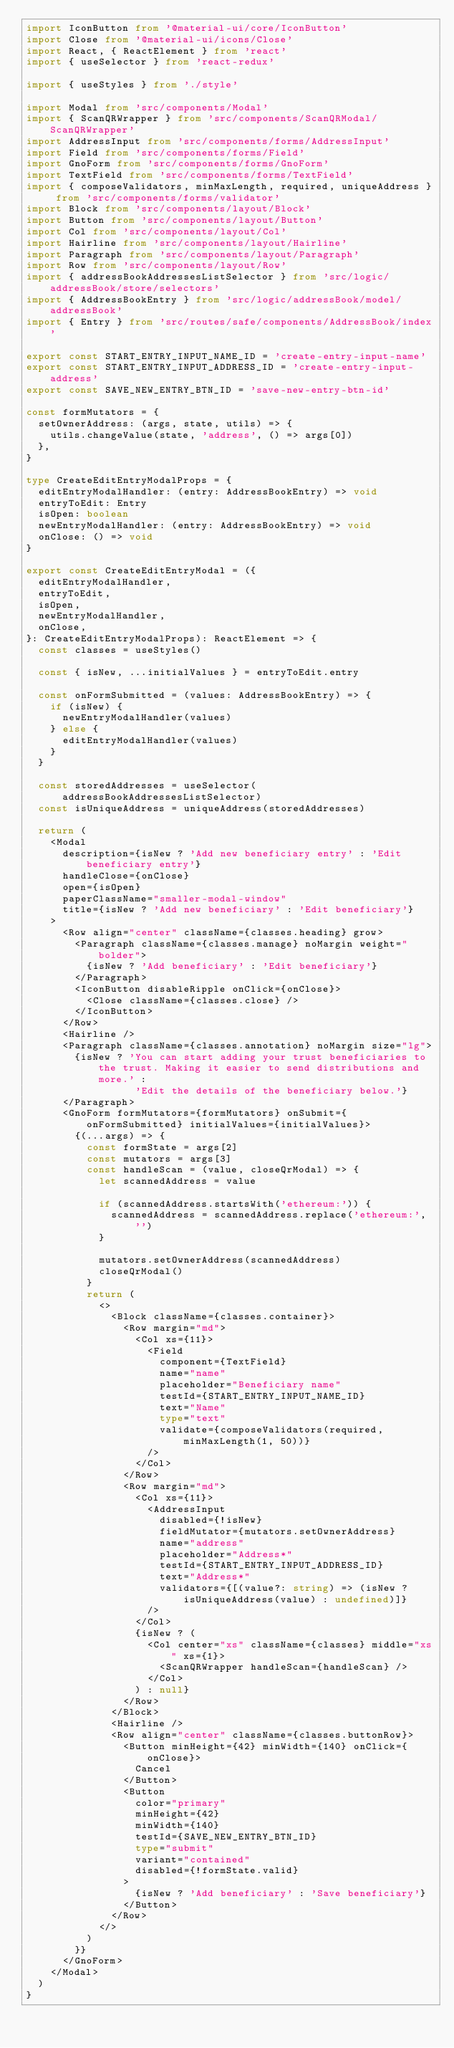<code> <loc_0><loc_0><loc_500><loc_500><_TypeScript_>import IconButton from '@material-ui/core/IconButton'
import Close from '@material-ui/icons/Close'
import React, { ReactElement } from 'react'
import { useSelector } from 'react-redux'

import { useStyles } from './style'

import Modal from 'src/components/Modal'
import { ScanQRWrapper } from 'src/components/ScanQRModal/ScanQRWrapper'
import AddressInput from 'src/components/forms/AddressInput'
import Field from 'src/components/forms/Field'
import GnoForm from 'src/components/forms/GnoForm'
import TextField from 'src/components/forms/TextField'
import { composeValidators, minMaxLength, required, uniqueAddress } from 'src/components/forms/validator'
import Block from 'src/components/layout/Block'
import Button from 'src/components/layout/Button'
import Col from 'src/components/layout/Col'
import Hairline from 'src/components/layout/Hairline'
import Paragraph from 'src/components/layout/Paragraph'
import Row from 'src/components/layout/Row'
import { addressBookAddressesListSelector } from 'src/logic/addressBook/store/selectors'
import { AddressBookEntry } from 'src/logic/addressBook/model/addressBook'
import { Entry } from 'src/routes/safe/components/AddressBook/index'

export const START_ENTRY_INPUT_NAME_ID = 'create-entry-input-name'
export const START_ENTRY_INPUT_ADDRESS_ID = 'create-entry-input-address'
export const SAVE_NEW_ENTRY_BTN_ID = 'save-new-entry-btn-id'

const formMutators = {
  setOwnerAddress: (args, state, utils) => {
    utils.changeValue(state, 'address', () => args[0])
  },
}

type CreateEditEntryModalProps = {
  editEntryModalHandler: (entry: AddressBookEntry) => void
  entryToEdit: Entry
  isOpen: boolean
  newEntryModalHandler: (entry: AddressBookEntry) => void
  onClose: () => void
}

export const CreateEditEntryModal = ({
  editEntryModalHandler,
  entryToEdit,
  isOpen,
  newEntryModalHandler,
  onClose,
}: CreateEditEntryModalProps): ReactElement => {
  const classes = useStyles()

  const { isNew, ...initialValues } = entryToEdit.entry

  const onFormSubmitted = (values: AddressBookEntry) => {
    if (isNew) {
      newEntryModalHandler(values)
    } else {
      editEntryModalHandler(values)
    }
  }

  const storedAddresses = useSelector(addressBookAddressesListSelector)
  const isUniqueAddress = uniqueAddress(storedAddresses)

  return (
    <Modal
      description={isNew ? 'Add new beneficiary entry' : 'Edit beneficiary entry'}
      handleClose={onClose}
      open={isOpen}
      paperClassName="smaller-modal-window"
      title={isNew ? 'Add new beneficiary' : 'Edit beneficiary'}
    >
      <Row align="center" className={classes.heading} grow>
        <Paragraph className={classes.manage} noMargin weight="bolder">
          {isNew ? 'Add beneficiary' : 'Edit beneficiary'}
        </Paragraph>
        <IconButton disableRipple onClick={onClose}>
          <Close className={classes.close} />
        </IconButton>
      </Row>
      <Hairline />
      <Paragraph className={classes.annotation} noMargin size="lg">
        {isNew ? 'You can start adding your trust beneficiaries to the trust. Making it easier to send distributions and more.' :
                  'Edit the details of the beneficiary below.'}
      </Paragraph>
      <GnoForm formMutators={formMutators} onSubmit={onFormSubmitted} initialValues={initialValues}>
        {(...args) => {
          const formState = args[2]
          const mutators = args[3]
          const handleScan = (value, closeQrModal) => {
            let scannedAddress = value

            if (scannedAddress.startsWith('ethereum:')) {
              scannedAddress = scannedAddress.replace('ethereum:', '')
            }

            mutators.setOwnerAddress(scannedAddress)
            closeQrModal()
          }
          return (
            <>
              <Block className={classes.container}>
                <Row margin="md">
                  <Col xs={11}>
                    <Field
                      component={TextField}
                      name="name"
                      placeholder="Beneficiary name"
                      testId={START_ENTRY_INPUT_NAME_ID}
                      text="Name"
                      type="text"
                      validate={composeValidators(required, minMaxLength(1, 50))}
                    />
                  </Col>
                </Row>
                <Row margin="md">
                  <Col xs={11}>
                    <AddressInput
                      disabled={!isNew}
                      fieldMutator={mutators.setOwnerAddress}
                      name="address"
                      placeholder="Address*"
                      testId={START_ENTRY_INPUT_ADDRESS_ID}
                      text="Address*"
                      validators={[(value?: string) => (isNew ? isUniqueAddress(value) : undefined)]}
                    />
                  </Col>
                  {isNew ? (
                    <Col center="xs" className={classes} middle="xs" xs={1}>
                      <ScanQRWrapper handleScan={handleScan} />
                    </Col>
                  ) : null}
                </Row>
              </Block>
              <Hairline />
              <Row align="center" className={classes.buttonRow}>
                <Button minHeight={42} minWidth={140} onClick={onClose}>
                  Cancel
                </Button>
                <Button
                  color="primary"
                  minHeight={42}
                  minWidth={140}
                  testId={SAVE_NEW_ENTRY_BTN_ID}
                  type="submit"
                  variant="contained"
                  disabled={!formState.valid}
                >
                  {isNew ? 'Add beneficiary' : 'Save beneficiary'}
                </Button>
              </Row>
            </>
          )
        }}
      </GnoForm>
    </Modal>
  )
}
</code> 